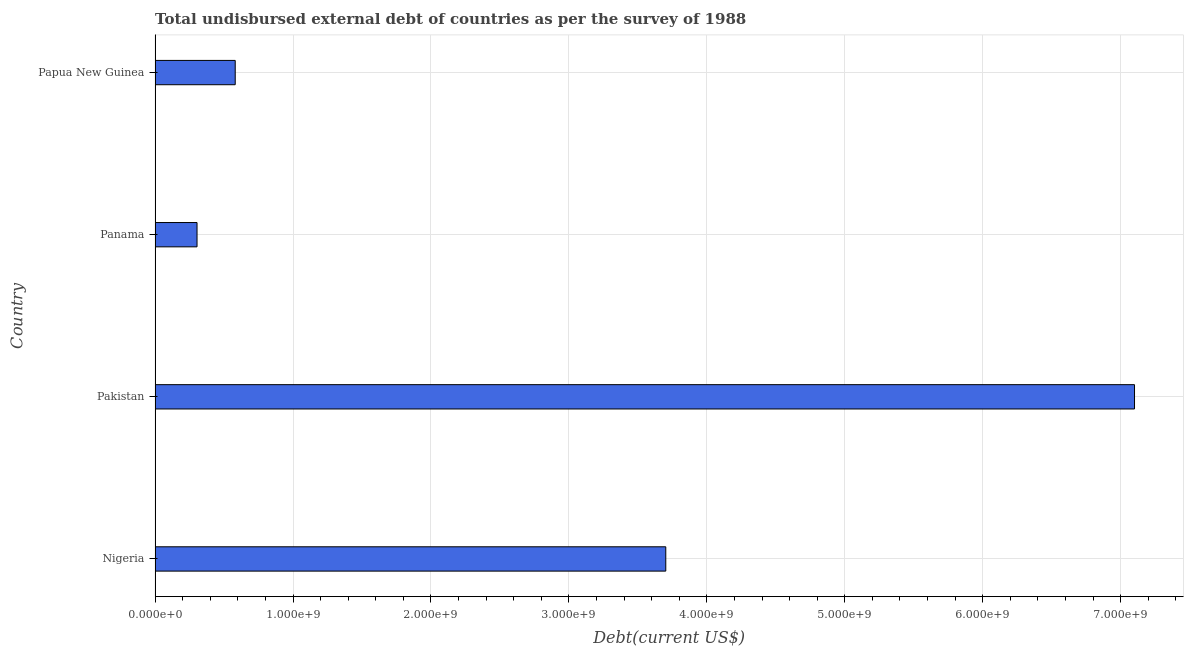Does the graph contain any zero values?
Your response must be concise. No. What is the title of the graph?
Offer a terse response. Total undisbursed external debt of countries as per the survey of 1988. What is the label or title of the X-axis?
Your response must be concise. Debt(current US$). What is the total debt in Pakistan?
Ensure brevity in your answer.  7.10e+09. Across all countries, what is the maximum total debt?
Give a very brief answer. 7.10e+09. Across all countries, what is the minimum total debt?
Offer a very short reply. 3.04e+08. In which country was the total debt maximum?
Offer a very short reply. Pakistan. In which country was the total debt minimum?
Keep it short and to the point. Panama. What is the sum of the total debt?
Provide a succinct answer. 1.17e+1. What is the difference between the total debt in Nigeria and Pakistan?
Provide a succinct answer. -3.40e+09. What is the average total debt per country?
Offer a very short reply. 2.92e+09. What is the median total debt?
Your answer should be compact. 2.14e+09. In how many countries, is the total debt greater than 5000000000 US$?
Provide a short and direct response. 1. What is the ratio of the total debt in Pakistan to that in Panama?
Offer a terse response. 23.34. Is the total debt in Nigeria less than that in Panama?
Provide a succinct answer. No. Is the difference between the total debt in Panama and Papua New Guinea greater than the difference between any two countries?
Ensure brevity in your answer.  No. What is the difference between the highest and the second highest total debt?
Give a very brief answer. 3.40e+09. What is the difference between the highest and the lowest total debt?
Offer a terse response. 6.80e+09. Are all the bars in the graph horizontal?
Keep it short and to the point. Yes. Are the values on the major ticks of X-axis written in scientific E-notation?
Make the answer very short. Yes. What is the Debt(current US$) in Nigeria?
Give a very brief answer. 3.70e+09. What is the Debt(current US$) in Pakistan?
Keep it short and to the point. 7.10e+09. What is the Debt(current US$) of Panama?
Offer a very short reply. 3.04e+08. What is the Debt(current US$) of Papua New Guinea?
Provide a short and direct response. 5.81e+08. What is the difference between the Debt(current US$) in Nigeria and Pakistan?
Provide a short and direct response. -3.40e+09. What is the difference between the Debt(current US$) in Nigeria and Panama?
Keep it short and to the point. 3.40e+09. What is the difference between the Debt(current US$) in Nigeria and Papua New Guinea?
Your answer should be very brief. 3.12e+09. What is the difference between the Debt(current US$) in Pakistan and Panama?
Make the answer very short. 6.80e+09. What is the difference between the Debt(current US$) in Pakistan and Papua New Guinea?
Offer a very short reply. 6.52e+09. What is the difference between the Debt(current US$) in Panama and Papua New Guinea?
Your response must be concise. -2.77e+08. What is the ratio of the Debt(current US$) in Nigeria to that in Pakistan?
Your answer should be compact. 0.52. What is the ratio of the Debt(current US$) in Nigeria to that in Panama?
Make the answer very short. 12.17. What is the ratio of the Debt(current US$) in Nigeria to that in Papua New Guinea?
Ensure brevity in your answer.  6.37. What is the ratio of the Debt(current US$) in Pakistan to that in Panama?
Your answer should be very brief. 23.34. What is the ratio of the Debt(current US$) in Pakistan to that in Papua New Guinea?
Give a very brief answer. 12.22. What is the ratio of the Debt(current US$) in Panama to that in Papua New Guinea?
Keep it short and to the point. 0.52. 